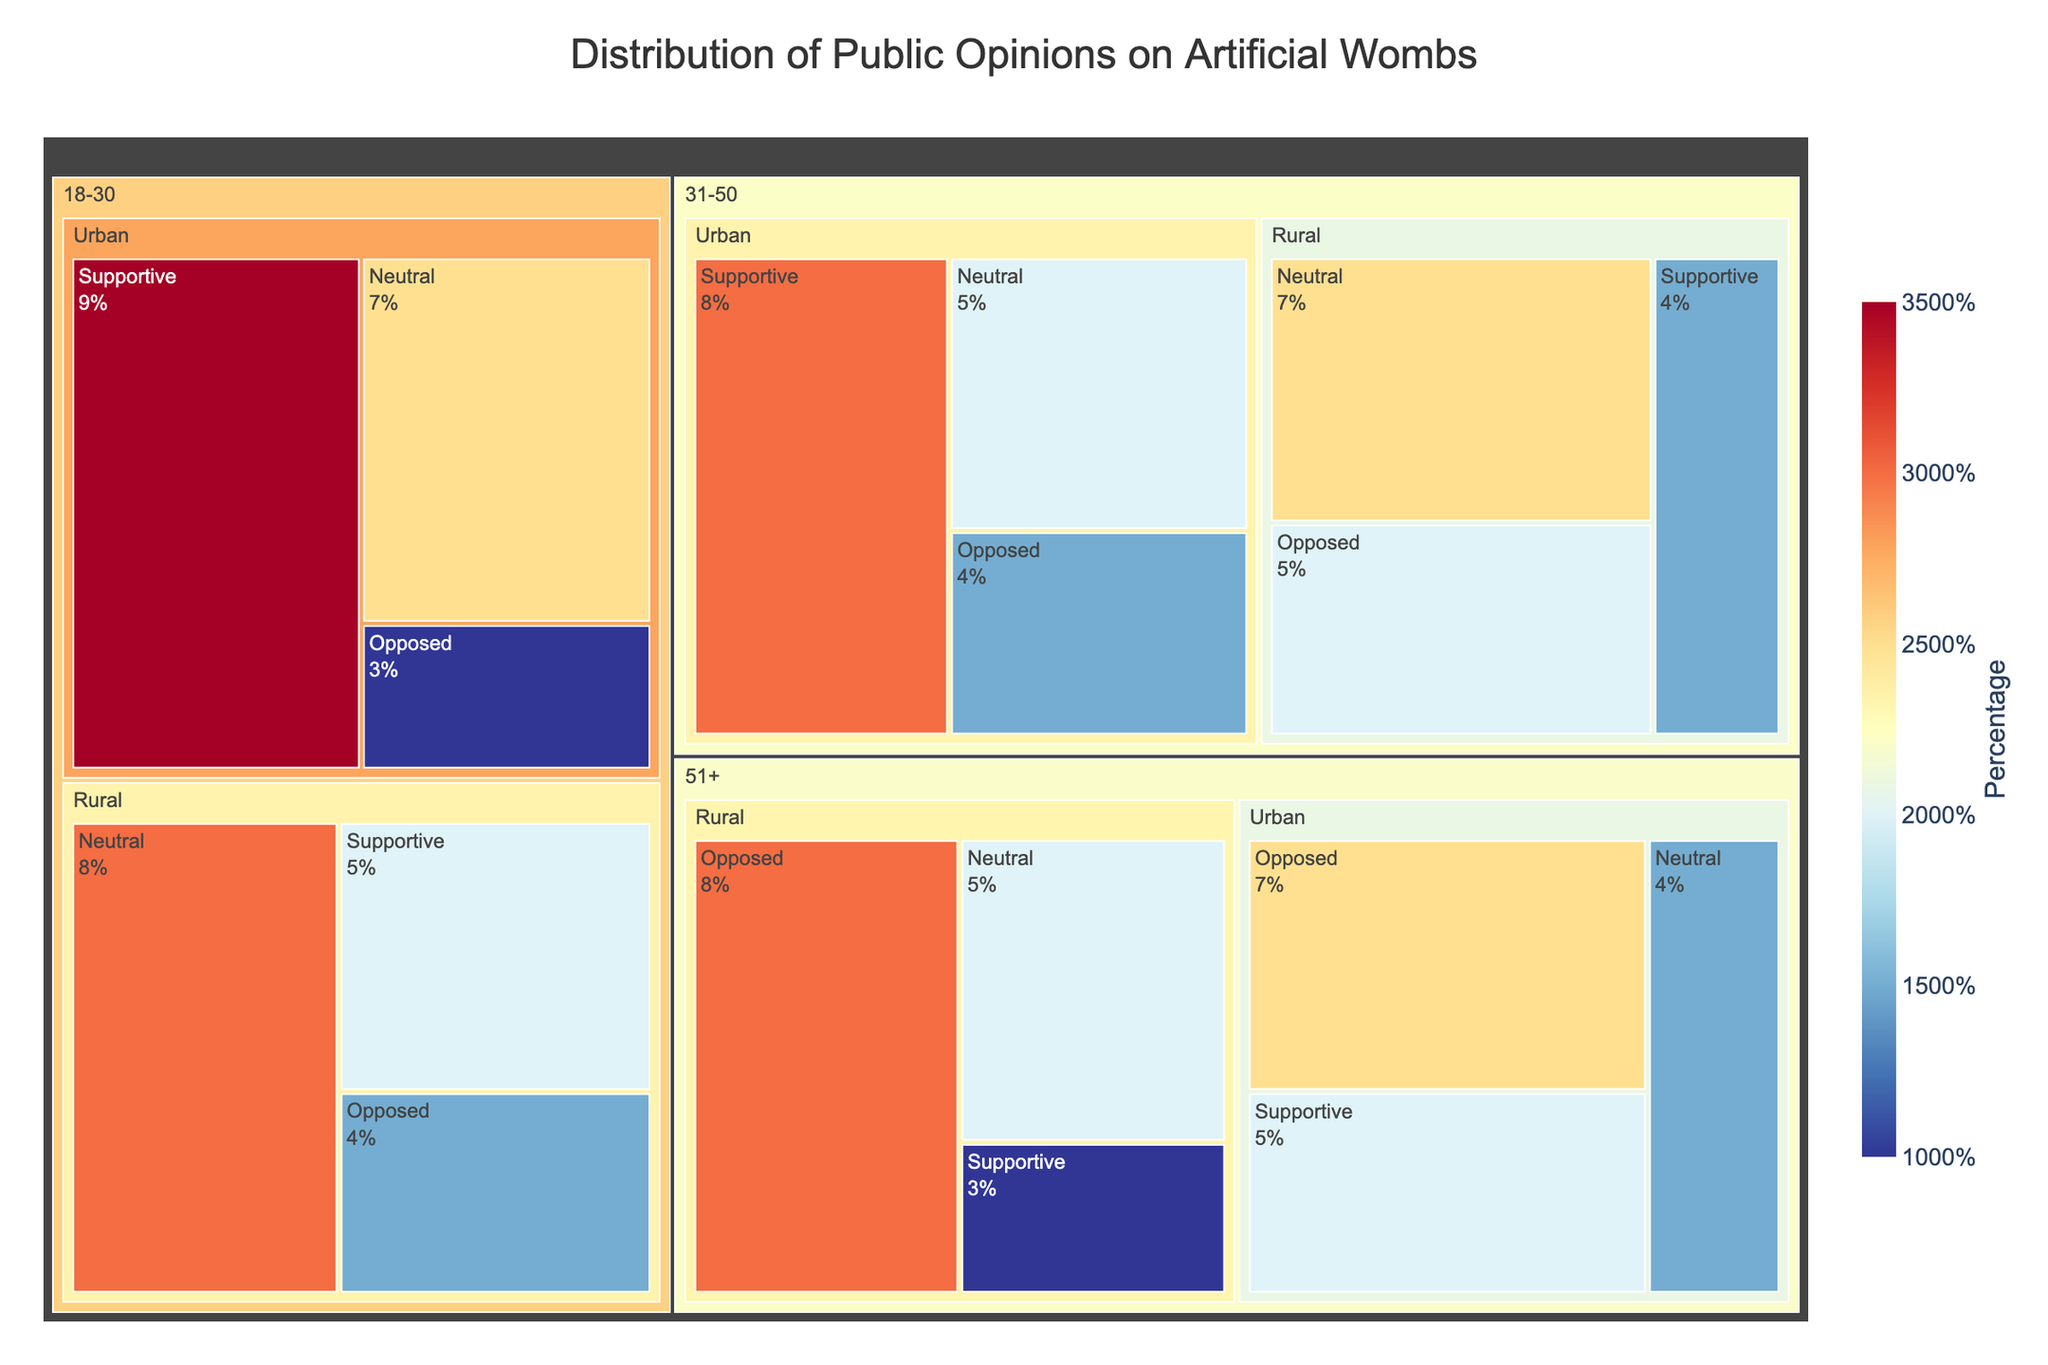How many age groups are represented in the figure? The figure shows data for three distinct age groups. These are 18-30, 31-50, and 51+.
Answer: 3 Which opinion category in the urban demographic for the 18-30 age group has the highest percentage? Among the 18-30 age group in the urban demographic, the 'Supportive' opinion category shows the highest percentage at 35%.
Answer: Supportive Compare the percentages of the 'Opposed' opinion in the rural demographic across all age groups. Which age group has the highest percentage? For the 'Opposed' opinion in the rural demographic, the percentages are 15% (18-30), 20% (31-50), and 30% (51+). The highest percentage is in the 51+ age group.
Answer: 51+ What is the total percentage of the 'Supportive' opinion across all groups? Adding the 'Supportive' percentages together: 35% (18-30 Urban) + 20% (18-30 Rural) + 30% (31-50 Urban) + 15% (31-50 Rural) + 20% (51+ Urban) + 10% (51+ Rural) results in 130%.
Answer: 130% Which demographic shows greater support for artificial wombs, urban or rural, in the age group 31-50? In the age group 31-50, the support in urban areas is 30%, while in rural areas, it is 15%. Therefore, the urban demographic is more supportive.
Answer: Urban What proportion of the 31-50 age group in rural areas is neutral? Looking at the distribution, 25% of the 31-50 age group in rural areas hold a neutral opinion.
Answer: 25% Between the 18-30 and 51+ age groups in urban areas, which has a higher percentage of neutrality? The 18-30 age group in urban areas has a neutrality percentage of 25%, whereas the 51+ age group has a neutrality percentage of 15%. The 18-30 age group is higher.
Answer: 18-30 How do the percentages compare between supportive opinions in urban and rural areas for the 51+ age group? For the 51+ age group, supportive opinions are 20% in urban areas and 10% in rural areas. Urban areas have a higher percentage.
Answer: Urban What is the percentage difference between the 'Neutral' opinions for 18-30 rural and 31-50 rural demographics? The 'Neutral' percentage for 18-30 rural is 30% and for 31-50 rural is 25%. The difference is 30% - 25% = 5%.
Answer: 5% What percentage of the 51+ age group in rural areas is either neutral or supportive? Adding the 'Neutral' (20%) and 'Supportive' (10%) categories together for the 51+ age group in rural areas results in 30%.
Answer: 30% 